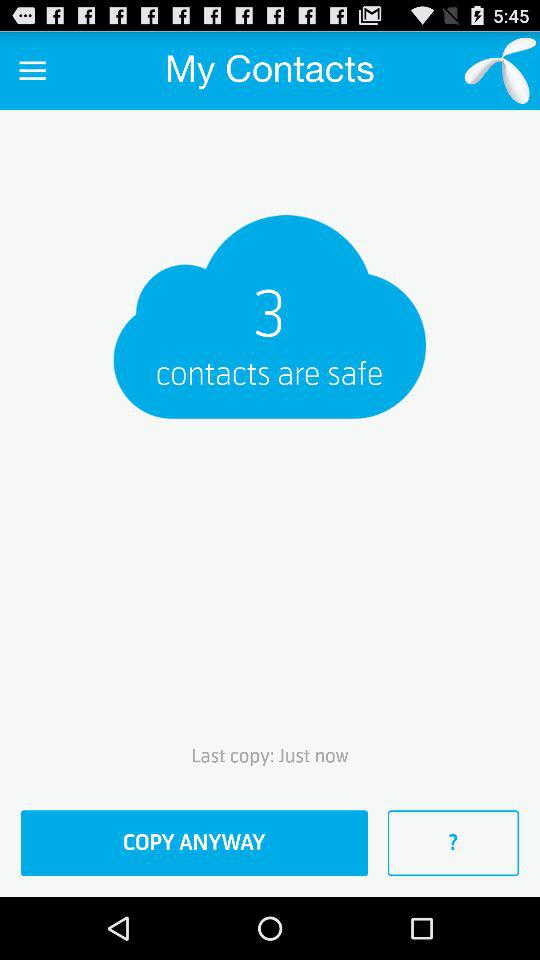What's the total number of safe contacts? The total number of safe contacts is 3. 